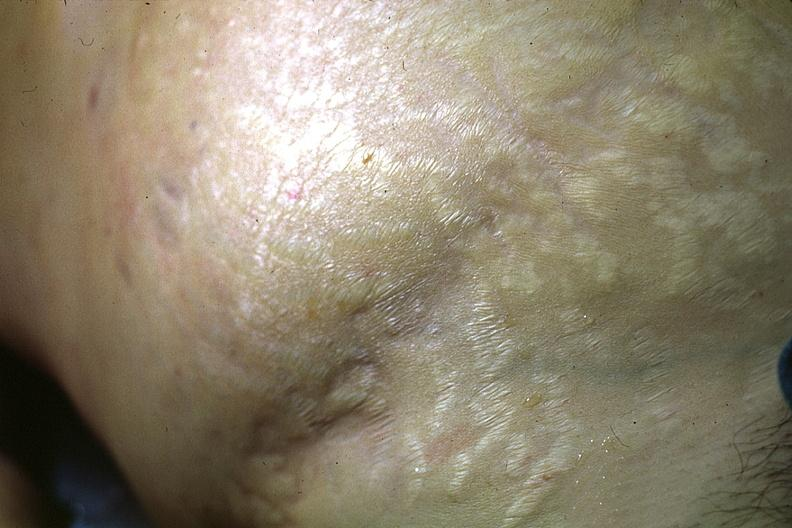what does this image show?
Answer the question using a single word or phrase. Good abdominal stria 